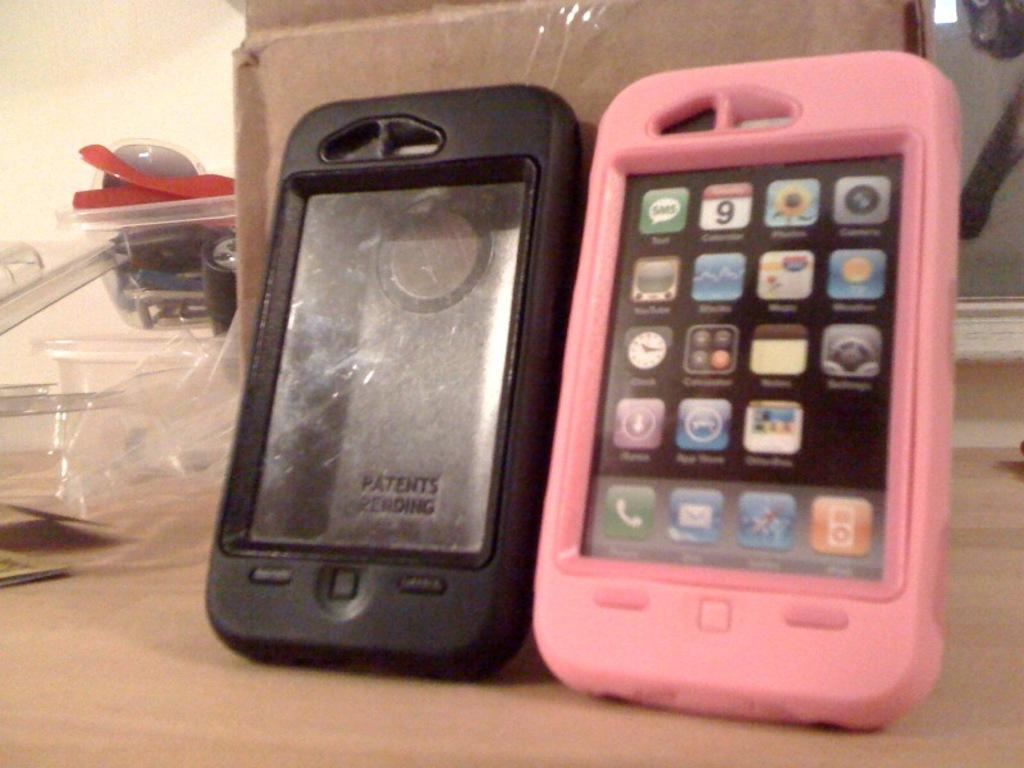What objects are present in the image related to mobile phones? There are two mobile phone covers in the image. What colors are the mobile phone covers? One mobile phone cover is pink, and the other is black. Where are the mobile phone covers located? The mobile phone covers are placed on a table. What else can be seen on the table in the image? There is a box visible in the image. What is located beside the box on the table? There are other things kept beside the box. What type of guide is provided with the mobile phone covers in the image? There is no guide present with the mobile phone covers in the image. 